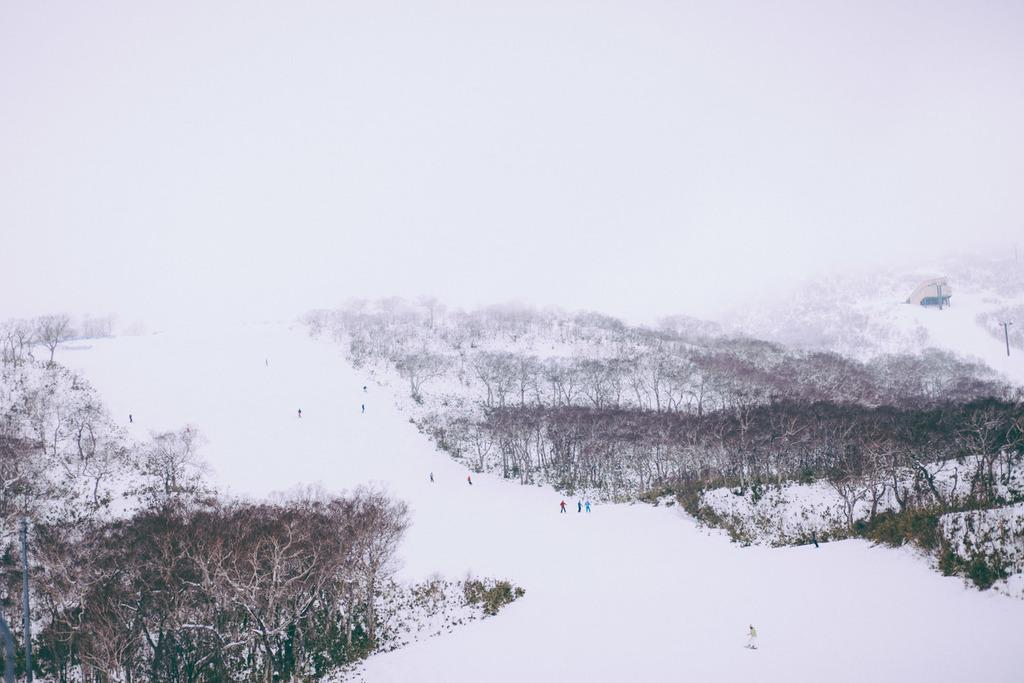Please provide a concise description of this image. In this image we can see sky, persons on the snow, electric pole and trees. 